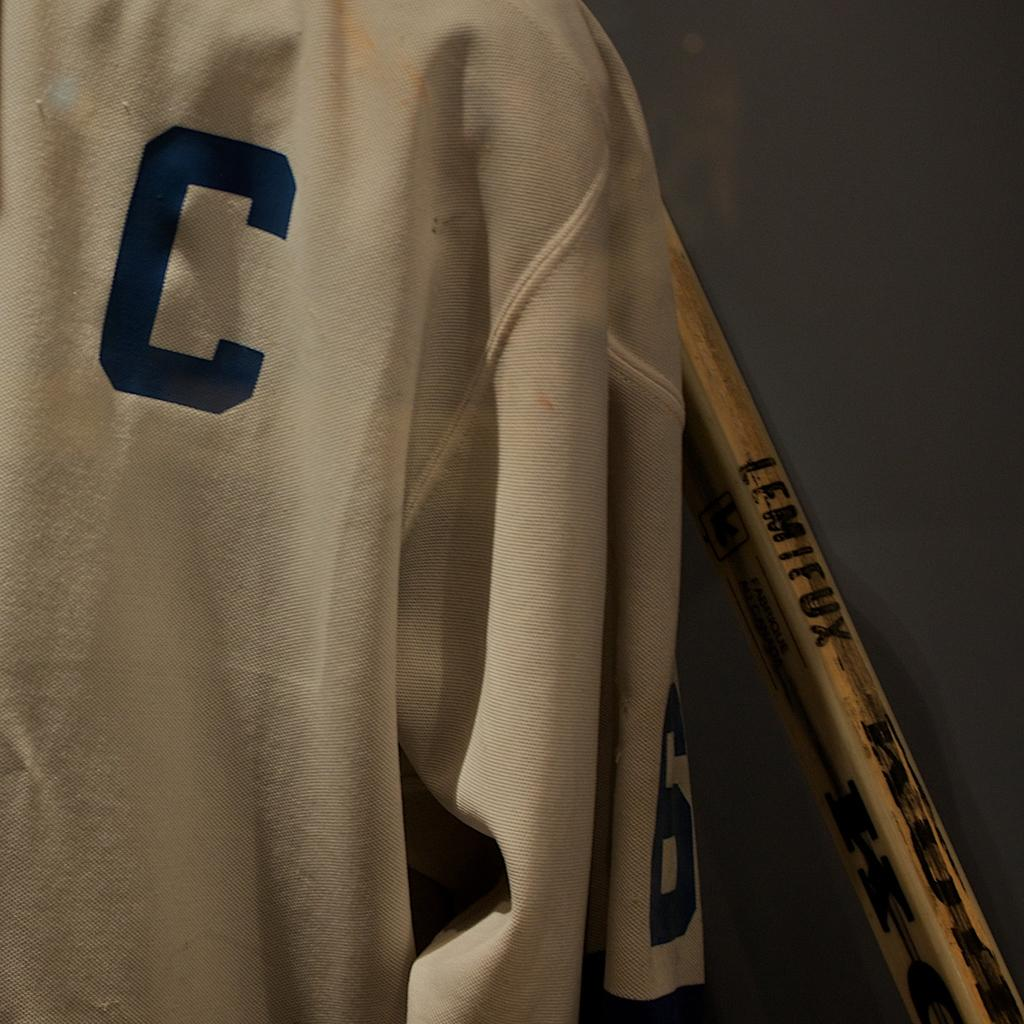<image>
Summarize the visual content of the image. a jersey with the letter C on the top right 